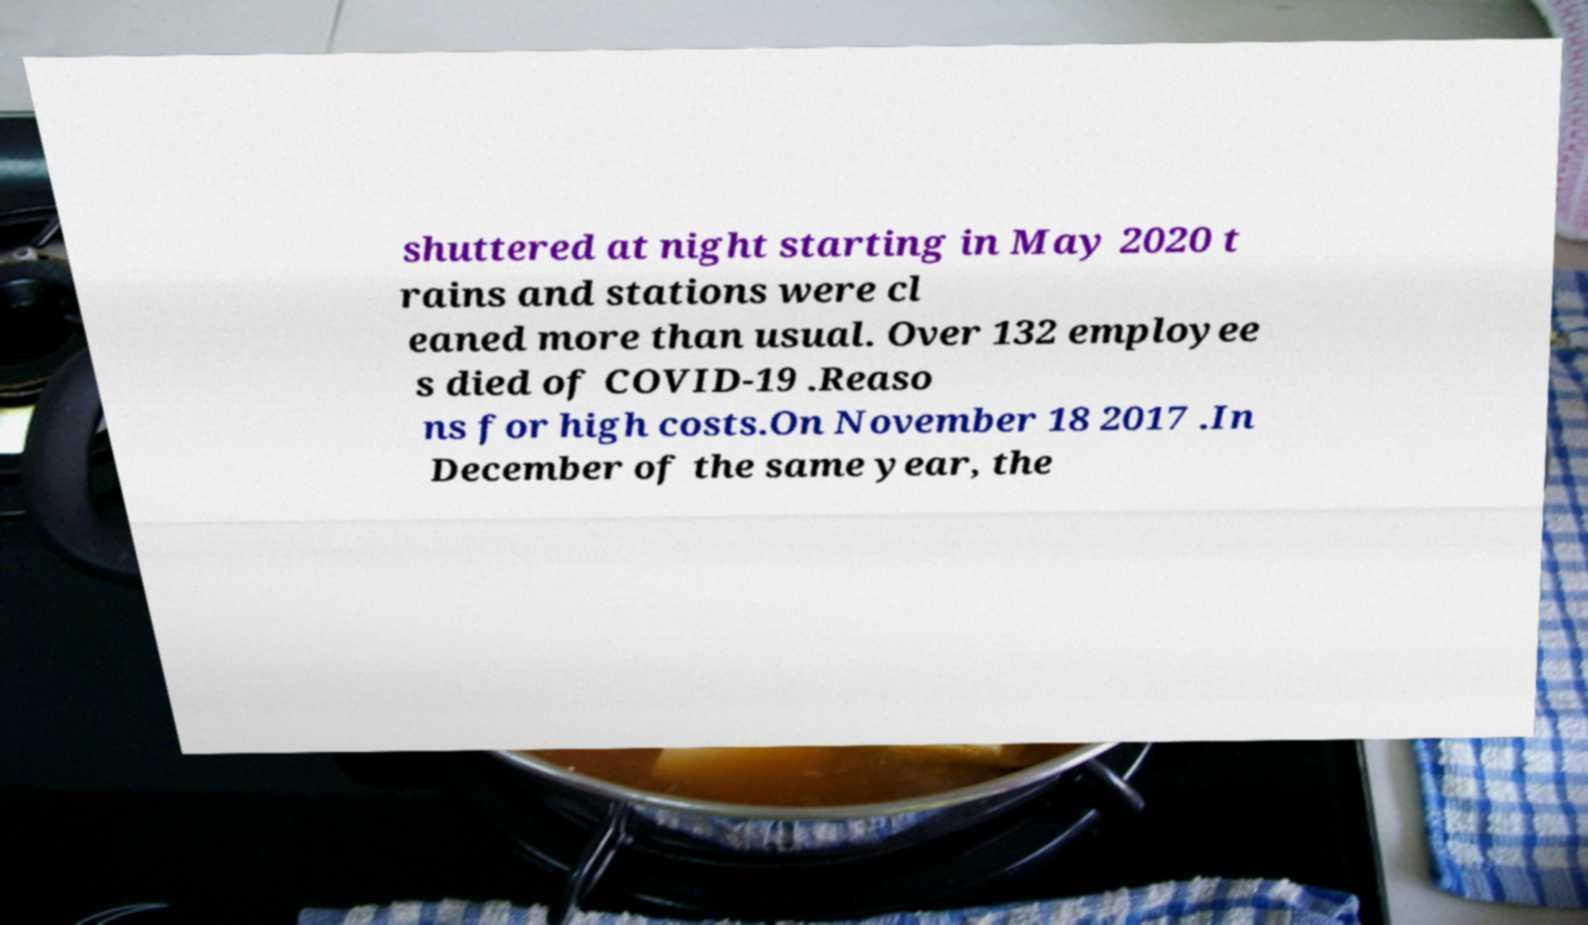Can you read and provide the text displayed in the image?This photo seems to have some interesting text. Can you extract and type it out for me? shuttered at night starting in May 2020 t rains and stations were cl eaned more than usual. Over 132 employee s died of COVID-19 .Reaso ns for high costs.On November 18 2017 .In December of the same year, the 